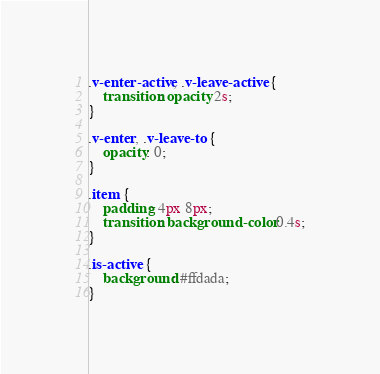Convert code to text. <code><loc_0><loc_0><loc_500><loc_500><_CSS_>.v-enter-active, .v-leave-active {
    transition: opacity 2s;
}

.v-enter, .v-leave-to {
    opacity: 0;
}

.item {
    padding: 4px 8px;
    transition: background-color 0.4s;
}

.is-active {
    background: #ffdada;
}</code> 